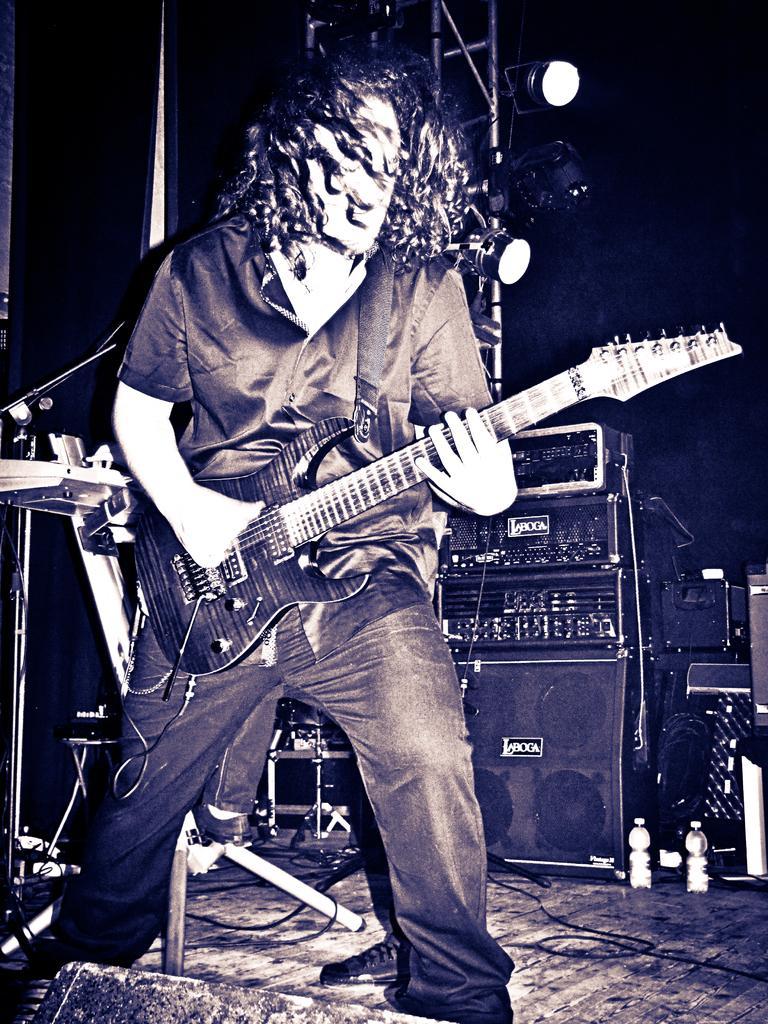Can you describe this image briefly? In this image I can see a person holding the guitar. 